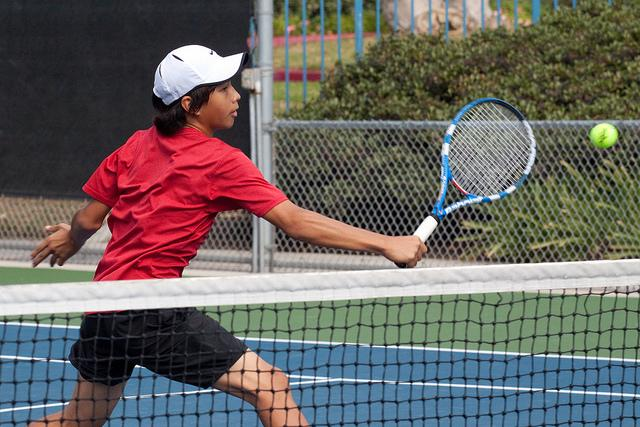Why is the boy reaching for the ball? Please explain your reasoning. to hit. The boy wants to hit the ball. 